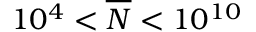<formula> <loc_0><loc_0><loc_500><loc_500>1 0 ^ { 4 } < \overline { N } < 1 0 ^ { 1 0 }</formula> 